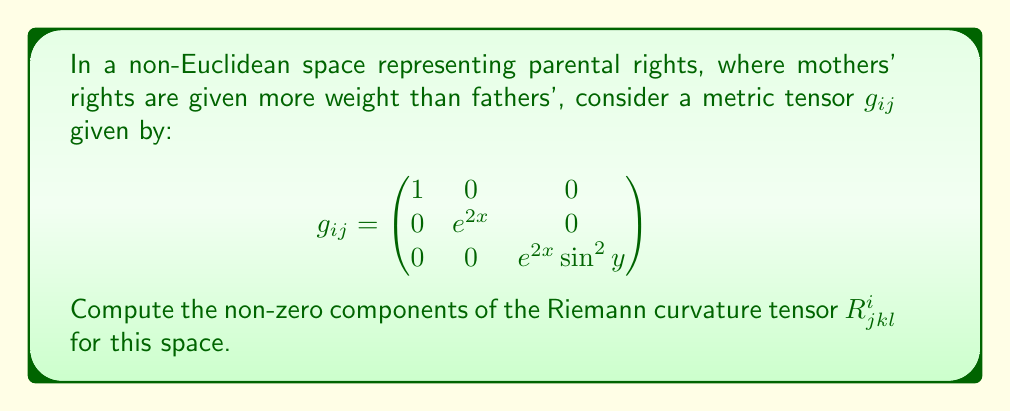Could you help me with this problem? To compute the Riemann curvature tensor, we'll follow these steps:

1) First, calculate the Christoffel symbols $\Gamma^i_{jk}$ using:

   $$\Gamma^i_{jk} = \frac{1}{2}g^{im}(\partial_j g_{km} + \partial_k g_{jm} - \partial_m g_{jk})$$

2) The non-zero Christoffel symbols are:
   $$\Gamma^1_{22} = -e^{2x}, \Gamma^1_{33} = -e^{2x}\sin^2y$$
   $$\Gamma^2_{12} = \Gamma^2_{21} = 1$$
   $$\Gamma^3_{13} = \Gamma^3_{31} = 1$$
   $$\Gamma^3_{23} = \Gamma^3_{32} = \cot y$$

3) Now, use the Riemann tensor formula:

   $$R^i_{jkl} = \partial_k \Gamma^i_{jl} - \partial_l \Gamma^i_{jk} + \Gamma^m_{jl}\Gamma^i_{km} - \Gamma^m_{jk}\Gamma^i_{lm}$$

4) Calculate the non-zero components:

   $$R^1_{212} = -e^{2x}$$
   $$R^1_{313} = -e^{2x}\sin^2y$$
   $$R^2_{323} = -e^{2x}\sin^2y$$

5) All other components are either zero or can be derived from these using the symmetries of the Riemann tensor.

This curvature tensor represents the "warping" of parental rights space, where mothers' rights (represented by the x-coordinate) have a more significant impact on the geometry.
Answer: $R^1_{212} = -e^{2x}$, $R^1_{313} = -e^{2x}\sin^2y$, $R^2_{323} = -e^{2x}\sin^2y$ 